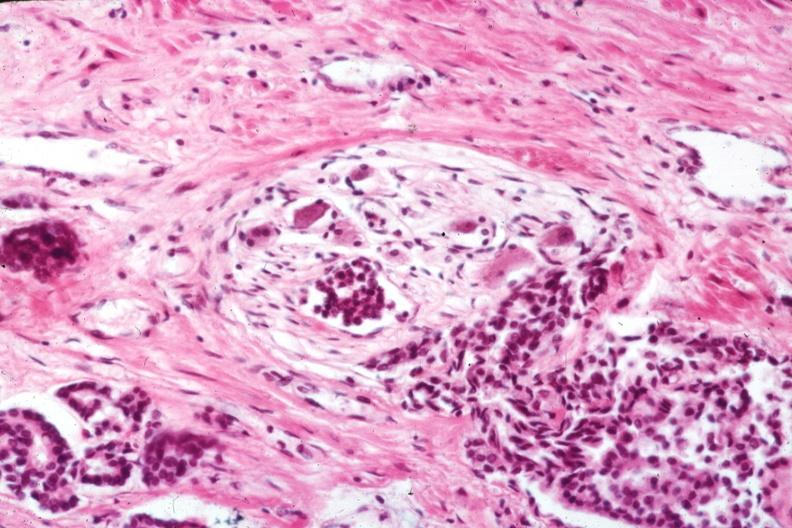what is present?
Answer the question using a single word or phrase. Prostate 